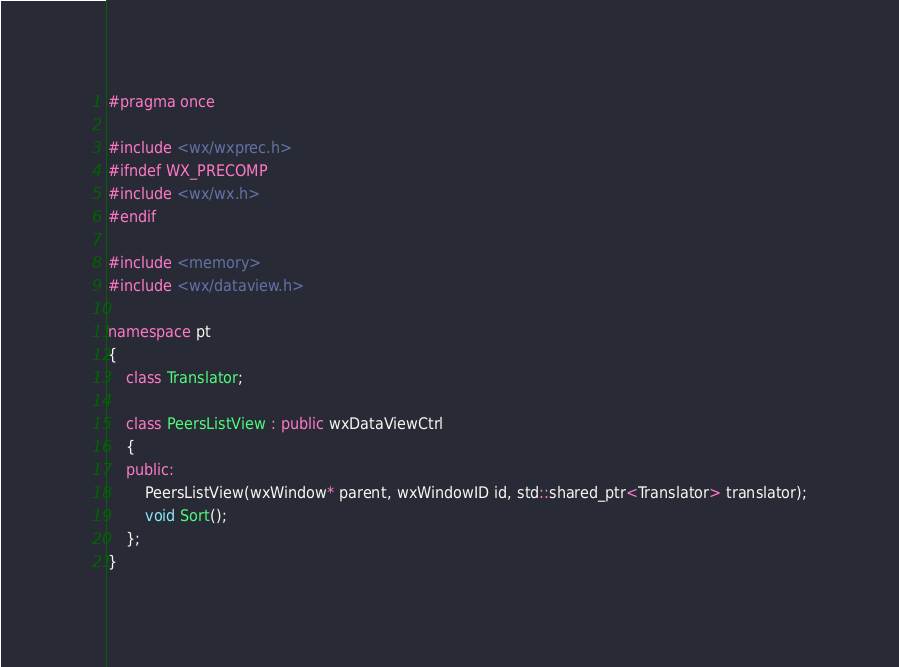Convert code to text. <code><loc_0><loc_0><loc_500><loc_500><_C++_>#pragma once

#include <wx/wxprec.h>
#ifndef WX_PRECOMP
#include <wx/wx.h>
#endif

#include <memory>
#include <wx/dataview.h>

namespace pt
{
    class Translator;

    class PeersListView : public wxDataViewCtrl
    {
    public:
        PeersListView(wxWindow* parent, wxWindowID id, std::shared_ptr<Translator> translator);
        void Sort();
    };
}
</code> 